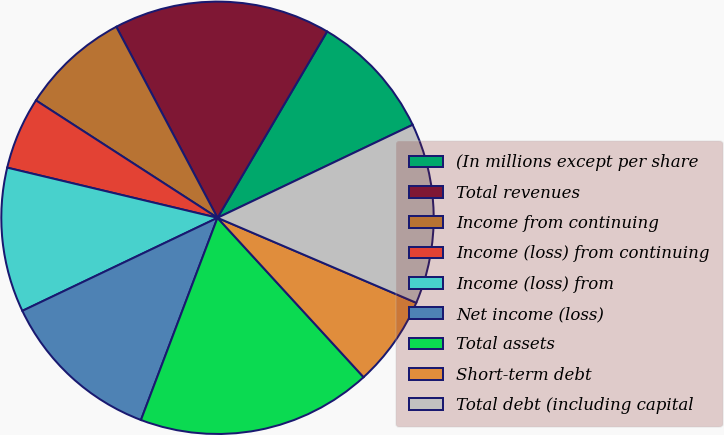Convert chart to OTSL. <chart><loc_0><loc_0><loc_500><loc_500><pie_chart><fcel>(In millions except per share<fcel>Total revenues<fcel>Income from continuing<fcel>Income (loss) from continuing<fcel>Income (loss) from<fcel>Net income (loss)<fcel>Total assets<fcel>Short-term debt<fcel>Total debt (including capital<nl><fcel>9.46%<fcel>16.22%<fcel>8.11%<fcel>5.41%<fcel>10.81%<fcel>12.16%<fcel>17.57%<fcel>6.76%<fcel>13.51%<nl></chart> 